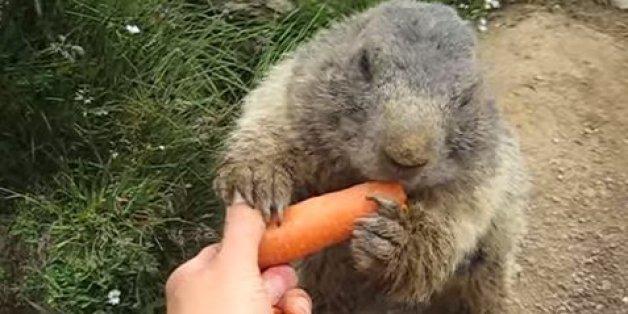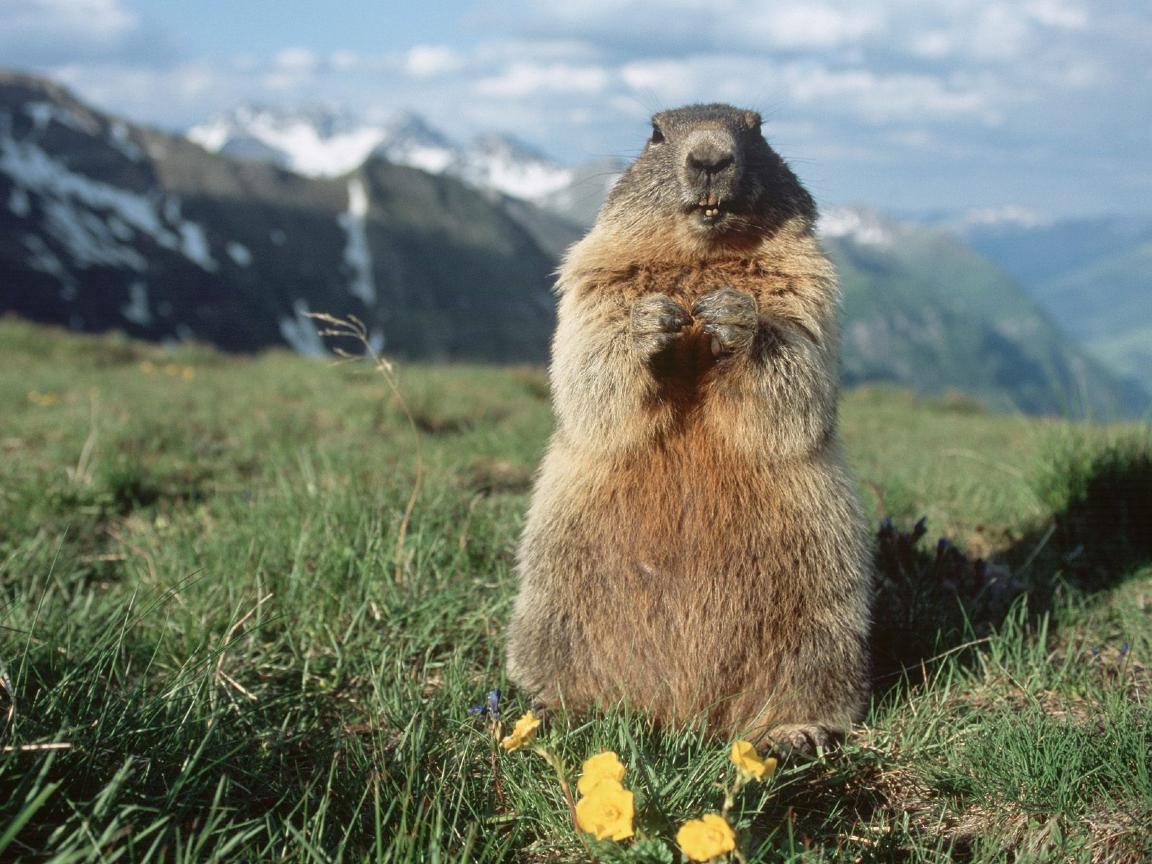The first image is the image on the left, the second image is the image on the right. Evaluate the accuracy of this statement regarding the images: "An image contains more than one rodent.". Is it true? Answer yes or no. No. 